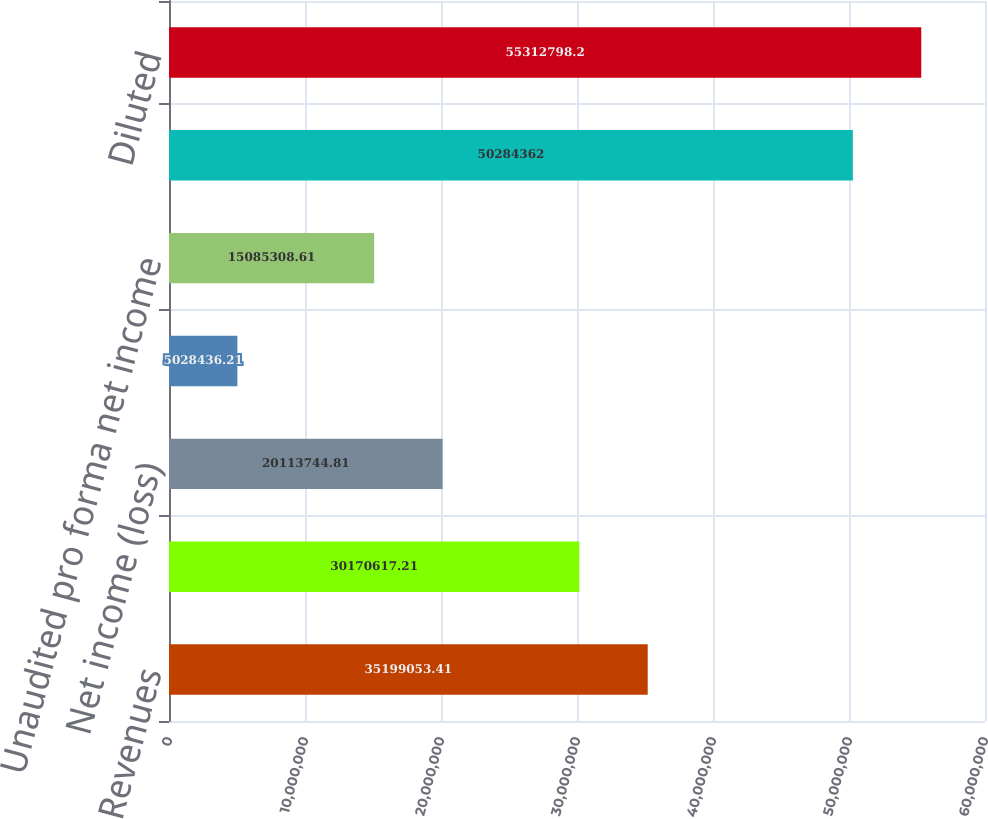<chart> <loc_0><loc_0><loc_500><loc_500><bar_chart><fcel>Revenues<fcel>Operating income<fcel>Net income (loss)<fcel>Net income (loss) per share<fcel>Unaudited pro forma net income<fcel>Basic<fcel>Diluted<nl><fcel>3.51991e+07<fcel>3.01706e+07<fcel>2.01137e+07<fcel>5.02844e+06<fcel>1.50853e+07<fcel>5.02844e+07<fcel>5.53128e+07<nl></chart> 